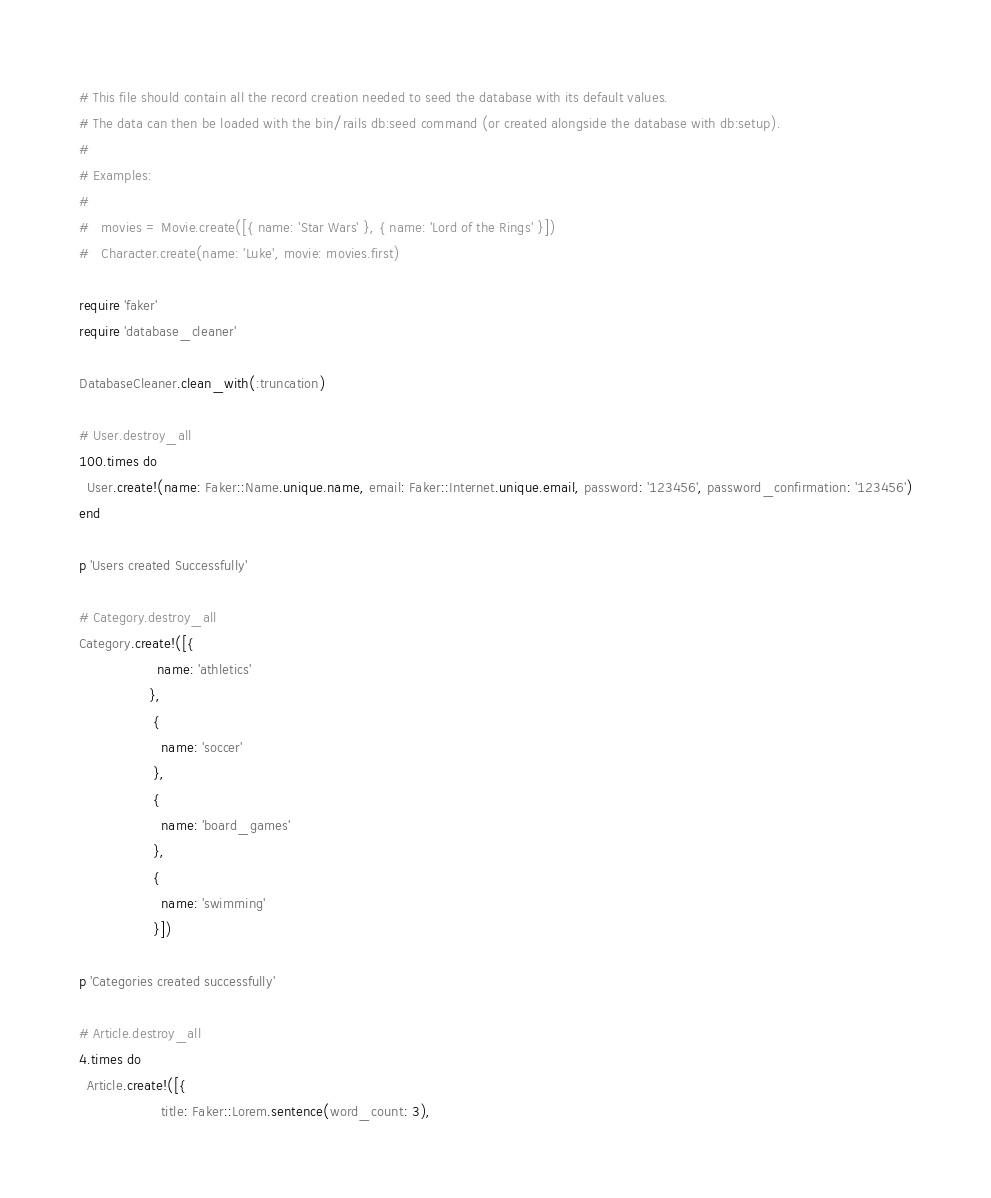Convert code to text. <code><loc_0><loc_0><loc_500><loc_500><_Ruby_># This file should contain all the record creation needed to seed the database with its default values.
# The data can then be loaded with the bin/rails db:seed command (or created alongside the database with db:setup).
#
# Examples:
#
#   movies = Movie.create([{ name: 'Star Wars' }, { name: 'Lord of the Rings' }])
#   Character.create(name: 'Luke', movie: movies.first)

require 'faker'
require 'database_cleaner'

DatabaseCleaner.clean_with(:truncation)

# User.destroy_all
100.times do
  User.create!(name: Faker::Name.unique.name, email: Faker::Internet.unique.email, password: '123456', password_confirmation: '123456')
end

p 'Users created Successfully'

# Category.destroy_all
Category.create!([{
                   name: 'athletics'
                 },
                  {
                    name: 'soccer'
                  },
                  {
                    name: 'board_games'
                  },
                  {
                    name: 'swimming'
                  }])

p 'Categories created successfully'

# Article.destroy_all
4.times do
  Article.create!([{
                    title: Faker::Lorem.sentence(word_count: 3),</code> 